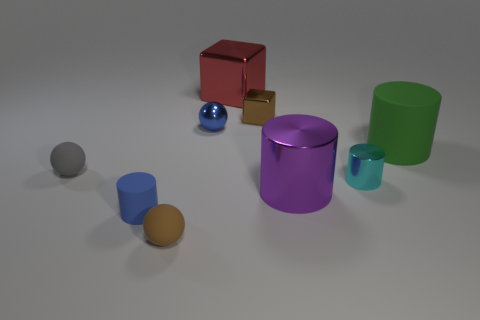What number of other objects are the same material as the tiny blue ball?
Keep it short and to the point. 4. How many things are both in front of the blue ball and to the right of the small gray ball?
Provide a succinct answer. 5. What color is the small matte cylinder?
Ensure brevity in your answer.  Blue. There is a small blue object that is the same shape as the small brown rubber object; what material is it?
Keep it short and to the point. Metal. Is the metal sphere the same color as the tiny matte cylinder?
Your answer should be very brief. Yes. The blue thing in front of the small rubber sphere to the left of the blue cylinder is what shape?
Your response must be concise. Cylinder. What is the shape of the purple thing that is the same material as the tiny cyan cylinder?
Your answer should be compact. Cylinder. How many other objects are there of the same shape as the purple shiny object?
Provide a succinct answer. 3. Do the blue thing in front of the purple cylinder and the large block have the same size?
Your answer should be compact. No. Are there more large metal things that are to the left of the brown shiny object than cyan objects?
Make the answer very short. No. 